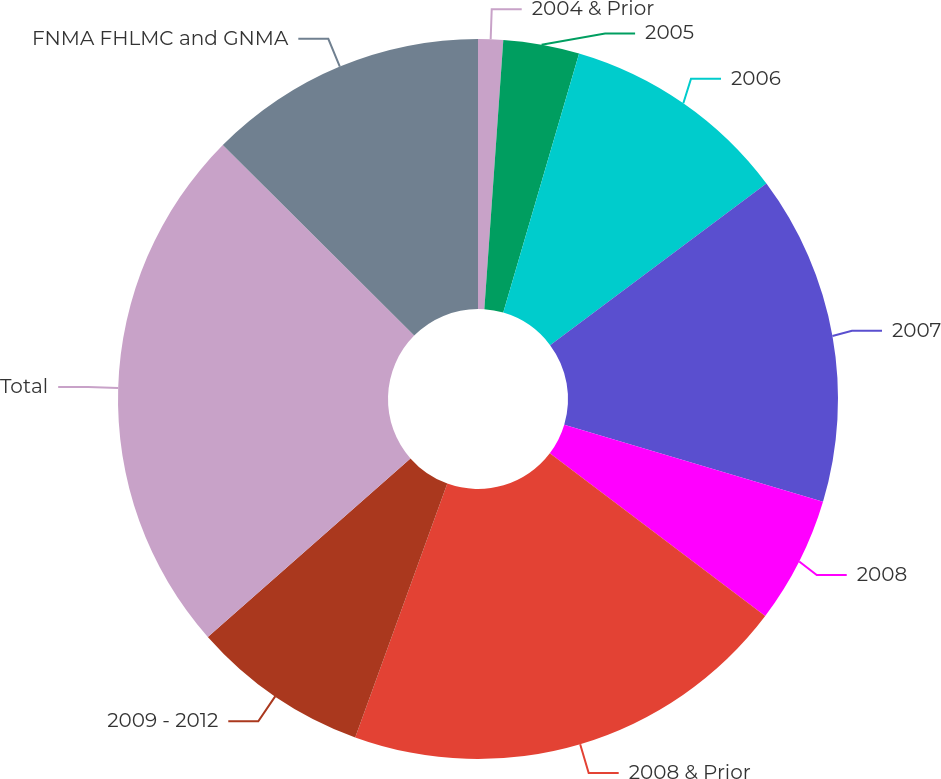<chart> <loc_0><loc_0><loc_500><loc_500><pie_chart><fcel>2004 & Prior<fcel>2005<fcel>2006<fcel>2007<fcel>2008<fcel>2008 & Prior<fcel>2009 - 2012<fcel>Total<fcel>FNMA FHLMC and GNMA<nl><fcel>1.12%<fcel>3.41%<fcel>10.26%<fcel>14.82%<fcel>5.69%<fcel>20.24%<fcel>7.97%<fcel>23.95%<fcel>12.54%<nl></chart> 